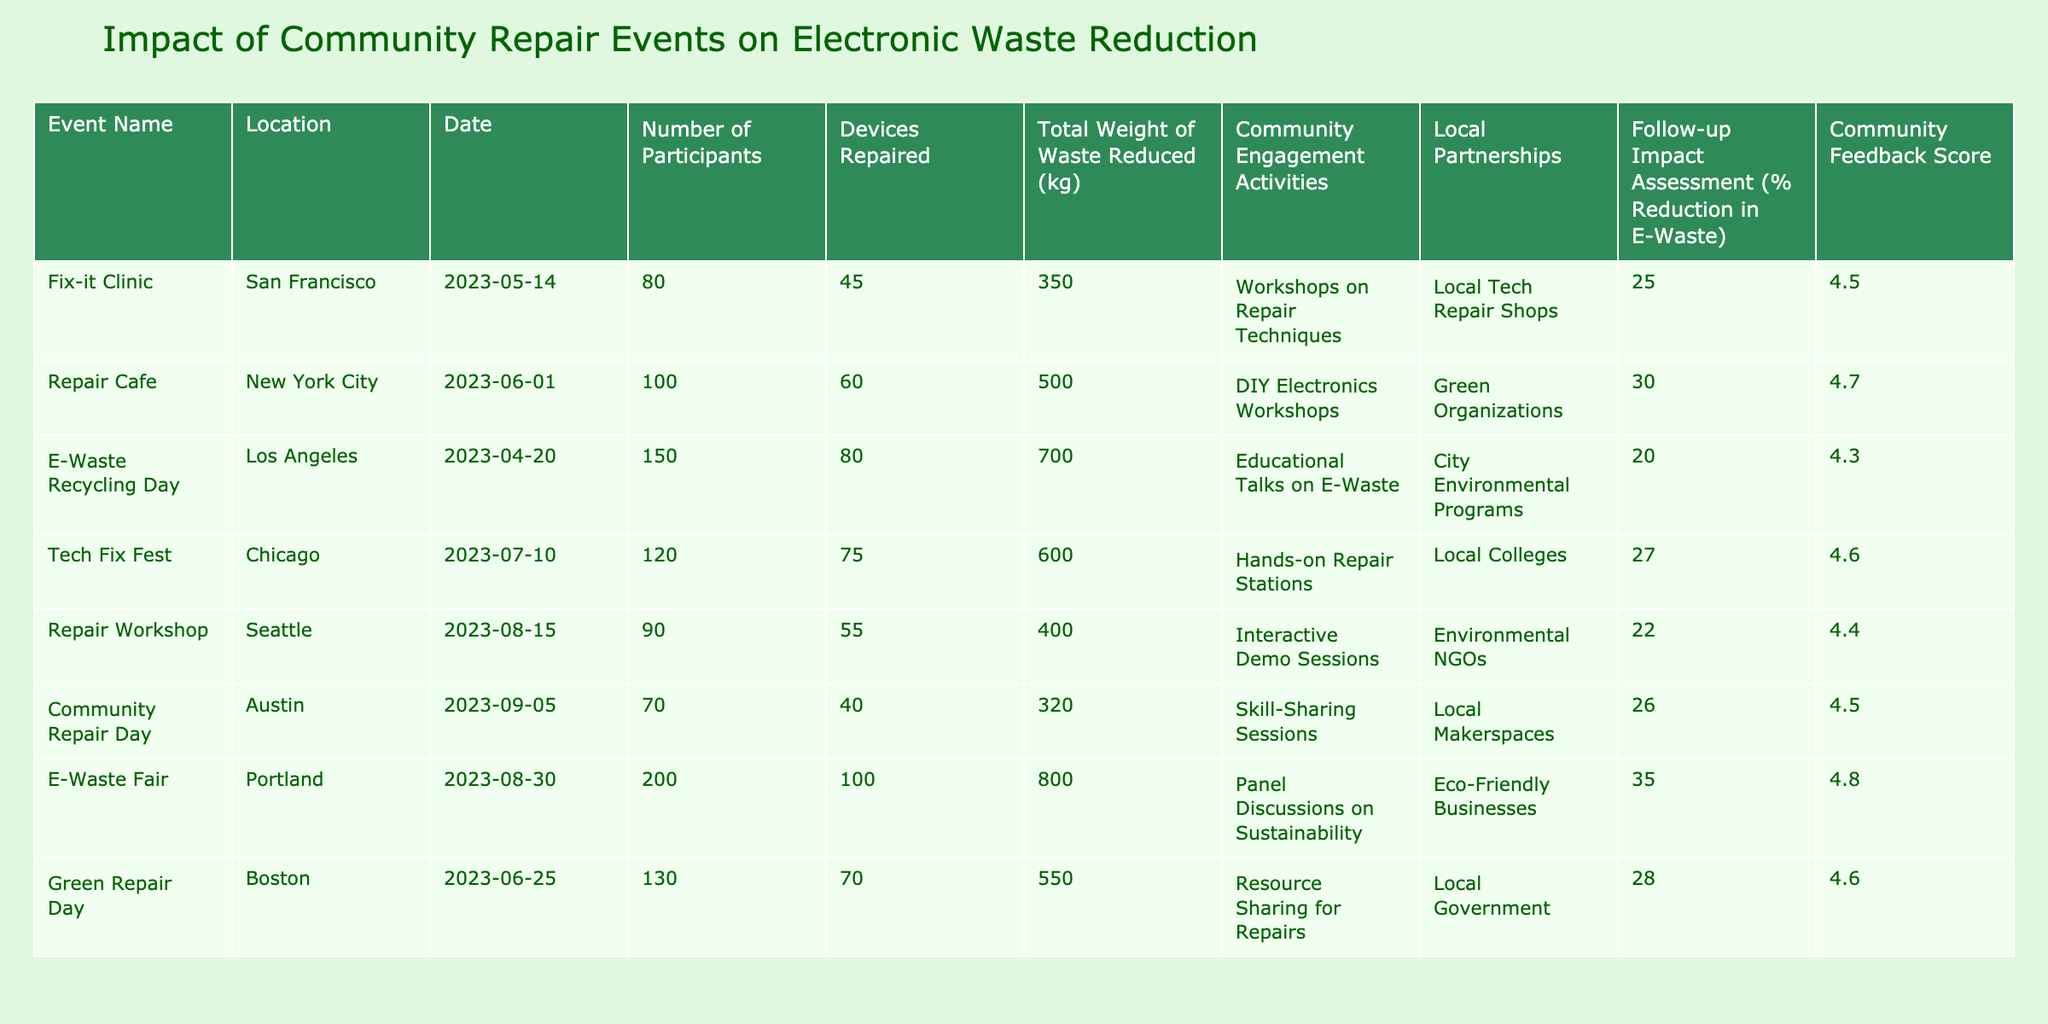What was the total weight of waste reduced in New York City during the Repair Cafe event? The table shows that the Repair Cafe event in New York City had a total weight of waste reduced of 500 kg.
Answer: 500 kg Which event had the highest percentage reduction in e-waste? Reviewing the table, the E-Waste Fair in Portland recorded the highest percentage reduction in e-waste at 35%.
Answer: 35% How many devices were repaired during the Fix-it Clinic in San Francisco? According to the table, 45 devices were repaired during the Fix-it Clinic event.
Answer: 45 What is the average community feedback score across all events? To find the average, sum all the community feedback scores: (4.5 + 4.7 + 4.3 + 4.6 + 4.4 + 4.5 + 4.8 + 4.6) = 36.4. There are 8 events, so the average is 36.4/8 = 4.55.
Answer: 4.55 Did the Tech Fix Fest have more participants than the Repair Workshop? The Tech Fix Fest had 120 participants, while the Repair Workshop had 90 participants, confirming that Tech Fix Fest had more participants.
Answer: Yes What was the total weight of waste reduced in events with community engagement activities focused on skill-sharing? The events with skill-sharing activities are the Community Repair Day in Austin (320 kg) and one other event if applicable. Summing up, the total weight reduced is 320 kg since no other event used skill-sharing.
Answer: 320 kg Which event had the most participants, and how many devices were repaired there? The event with the most participants was the E-Waste Fair in Portland, with 200 participants. It also had 100 devices repaired.
Answer: 100 devices Is there a correlation between the number of participants and the total weight of waste reduced? Analyzing the table, we would look at the participants and weight reduced for all events, generally seeing more participants leading to more waste reduced, so yes, a positive correlation is evident.
Answer: Yes What percentage reduction in e-waste was achieved during the E-Waste Recycling Day compared to the event with the closest participant count? E-Waste Recycling Day achieved a 20% reduction, while the closest event in terms of participants is the Tech Fix Fest with 120 participants and a 27% reduction. The E-Waste Recycling Day had the lower percentage reduction of the two.
Answer: 20% Which event is associated with the highest community engagement activity score and what was the score? The event with the highest community engagement activities was the E-Waste Fair in Portland featuring panel discussions on sustainability, and its community feedback score is 4.8.
Answer: 4.8 